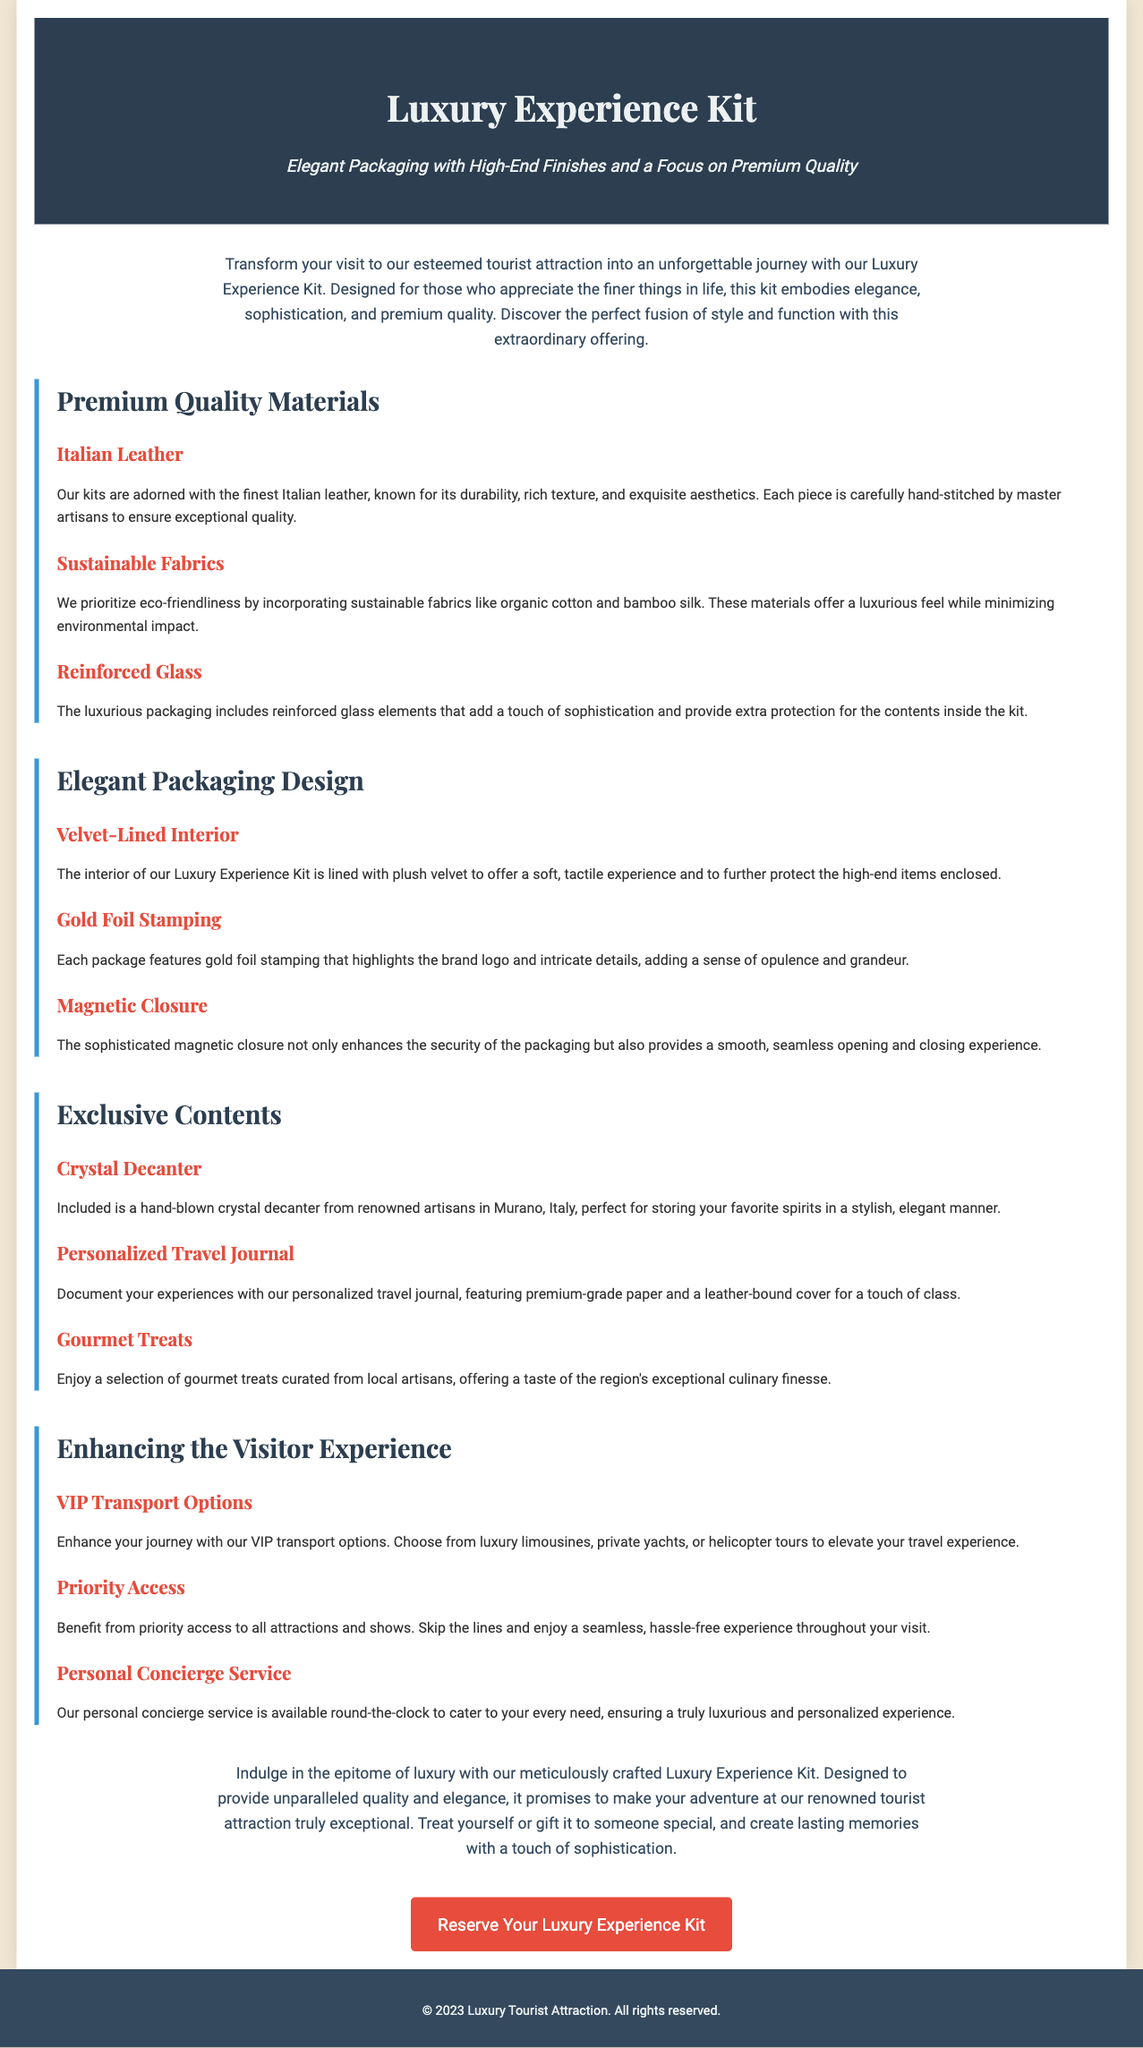What materials are used in the Luxury Experience Kit? The document lists Italian leather, sustainable fabrics, and reinforced glass as the materials used in the Luxury Experience Kit.
Answer: Italian leather, sustainable fabrics, reinforced glass What is featured in the Luxury Experience Kit's elegant packaging? The packaging includes a velvet-lined interior, gold foil stamping, and a magnetic closure to enhance its elegance.
Answer: Velvet-lined interior, gold foil stamping, magnetic closure How many exclusive items are mentioned in the Luxury Experience Kit? The document lists three exclusive items: a crystal decanter, a personalized travel journal, and gourmet treats.
Answer: Three What type of transport options enhance the visitor experience? VIP transport options include luxury limousines, private yachts, and helicopter tours as mentioned in the document.
Answer: Luxury limousines, private yachts, helicopter tours What special service is provided 24/7 in the Luxury Experience Kit? The document mentions a personal concierge service that is available round-the-clock for the visitors.
Answer: Personal concierge service What aspect of the kit aims to minimize environmental impact? The Luxury Experience Kit incorporates sustainable fabrics like organic cotton and bamboo silk, which minimize environmental impact.
Answer: Sustainable fabrics What is the purpose of the Luxury Experience Kit? The kit is designed to transform visits into an unforgettable journey and to provide elegance and sophistication.
Answer: Unforgettable journey What type of aesthetic does the Luxury Experience Kit emphasize? The document emphasizes an aesthetic that embodies elegance, sophistication, and premium quality.
Answer: Elegance, sophistication, premium quality 